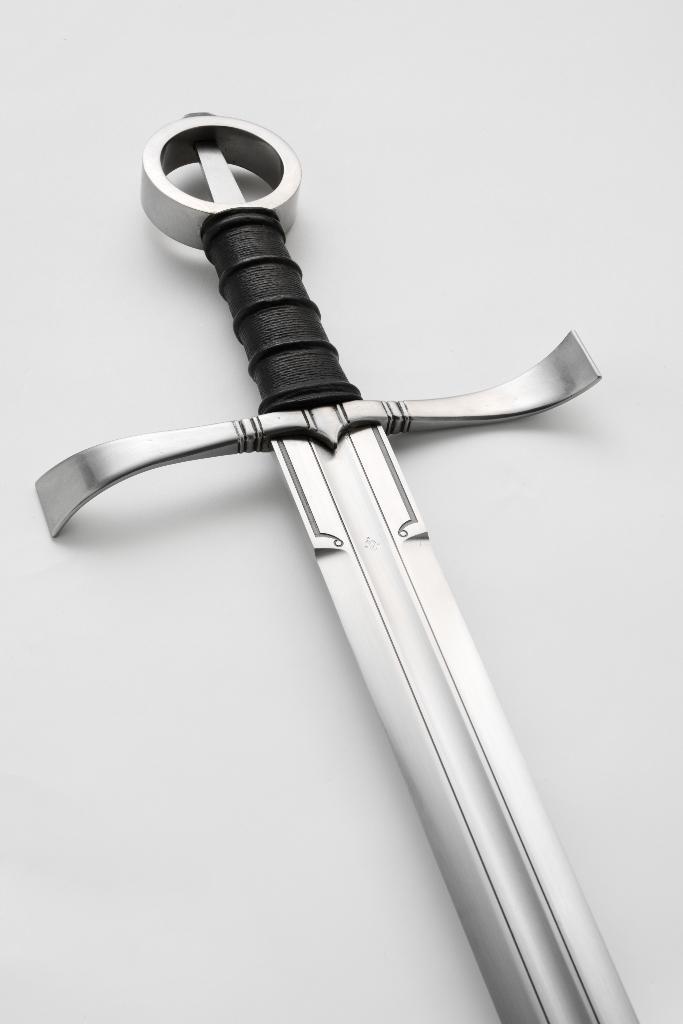Can you describe this image briefly? In the picture I can see a sword. 